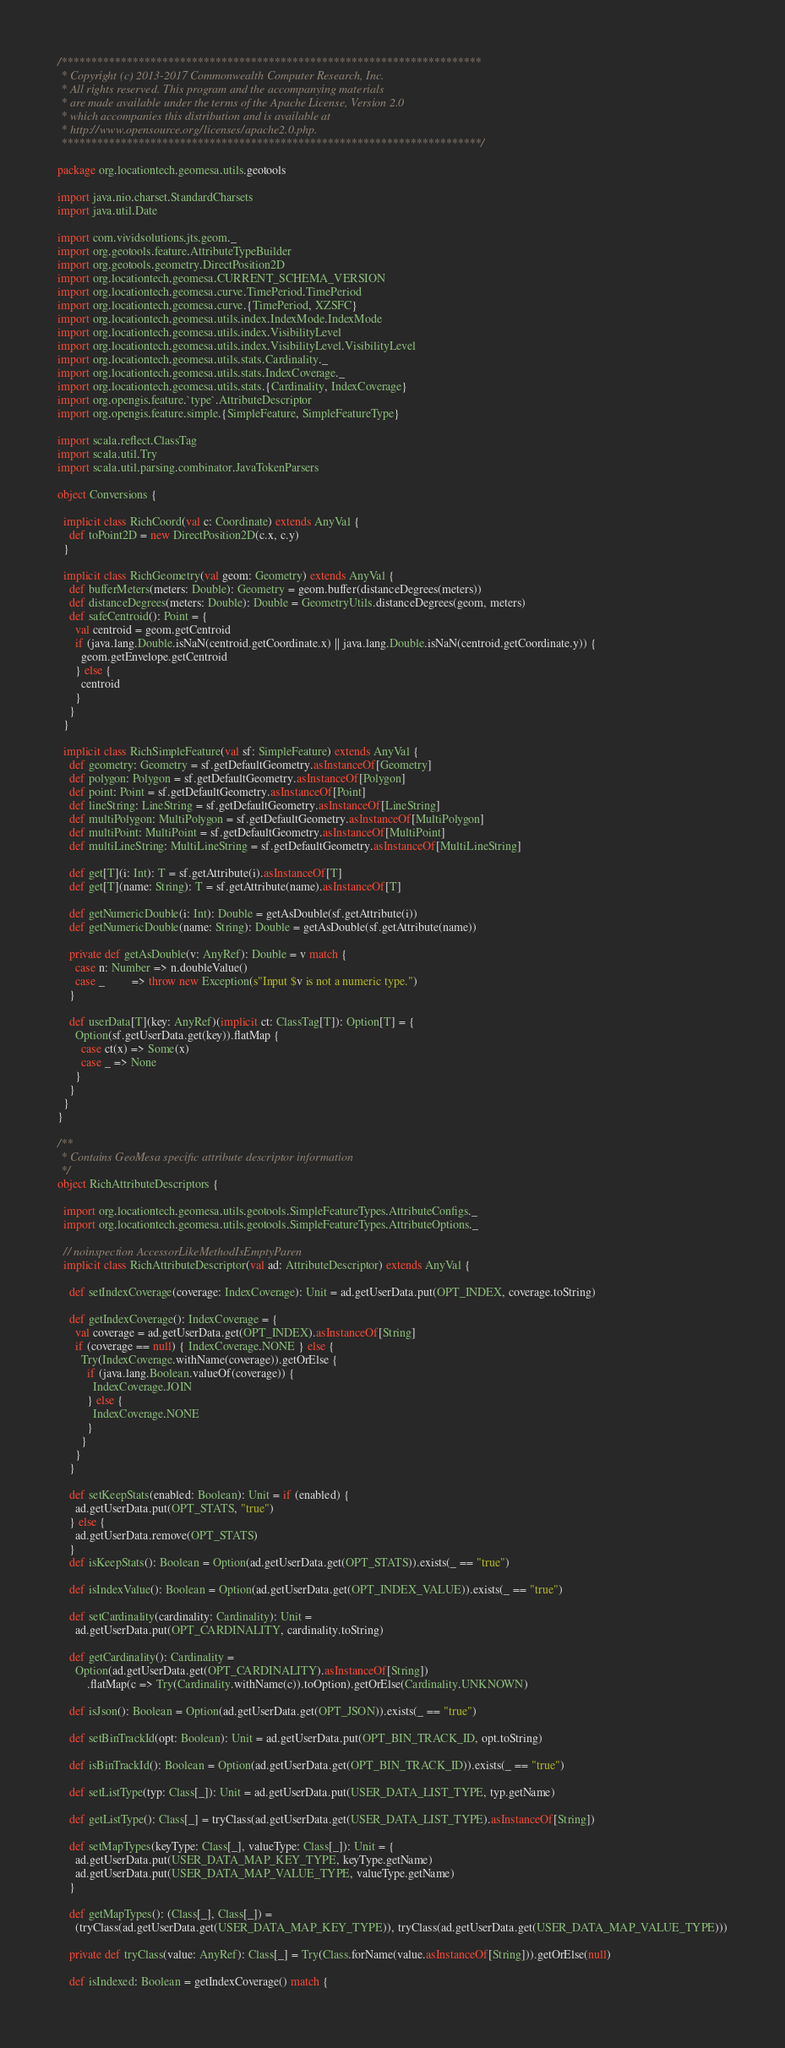Convert code to text. <code><loc_0><loc_0><loc_500><loc_500><_Scala_>/***********************************************************************
 * Copyright (c) 2013-2017 Commonwealth Computer Research, Inc.
 * All rights reserved. This program and the accompanying materials
 * are made available under the terms of the Apache License, Version 2.0
 * which accompanies this distribution and is available at
 * http://www.opensource.org/licenses/apache2.0.php.
 ***********************************************************************/

package org.locationtech.geomesa.utils.geotools

import java.nio.charset.StandardCharsets
import java.util.Date

import com.vividsolutions.jts.geom._
import org.geotools.feature.AttributeTypeBuilder
import org.geotools.geometry.DirectPosition2D
import org.locationtech.geomesa.CURRENT_SCHEMA_VERSION
import org.locationtech.geomesa.curve.TimePeriod.TimePeriod
import org.locationtech.geomesa.curve.{TimePeriod, XZSFC}
import org.locationtech.geomesa.utils.index.IndexMode.IndexMode
import org.locationtech.geomesa.utils.index.VisibilityLevel
import org.locationtech.geomesa.utils.index.VisibilityLevel.VisibilityLevel
import org.locationtech.geomesa.utils.stats.Cardinality._
import org.locationtech.geomesa.utils.stats.IndexCoverage._
import org.locationtech.geomesa.utils.stats.{Cardinality, IndexCoverage}
import org.opengis.feature.`type`.AttributeDescriptor
import org.opengis.feature.simple.{SimpleFeature, SimpleFeatureType}

import scala.reflect.ClassTag
import scala.util.Try
import scala.util.parsing.combinator.JavaTokenParsers

object Conversions {

  implicit class RichCoord(val c: Coordinate) extends AnyVal {
    def toPoint2D = new DirectPosition2D(c.x, c.y)
  }

  implicit class RichGeometry(val geom: Geometry) extends AnyVal {
    def bufferMeters(meters: Double): Geometry = geom.buffer(distanceDegrees(meters))
    def distanceDegrees(meters: Double): Double = GeometryUtils.distanceDegrees(geom, meters)
    def safeCentroid(): Point = {
      val centroid = geom.getCentroid
      if (java.lang.Double.isNaN(centroid.getCoordinate.x) || java.lang.Double.isNaN(centroid.getCoordinate.y)) {
        geom.getEnvelope.getCentroid
      } else {
        centroid
      }
    }
  }

  implicit class RichSimpleFeature(val sf: SimpleFeature) extends AnyVal {
    def geometry: Geometry = sf.getDefaultGeometry.asInstanceOf[Geometry]
    def polygon: Polygon = sf.getDefaultGeometry.asInstanceOf[Polygon]
    def point: Point = sf.getDefaultGeometry.asInstanceOf[Point]
    def lineString: LineString = sf.getDefaultGeometry.asInstanceOf[LineString]
    def multiPolygon: MultiPolygon = sf.getDefaultGeometry.asInstanceOf[MultiPolygon]
    def multiPoint: MultiPoint = sf.getDefaultGeometry.asInstanceOf[MultiPoint]
    def multiLineString: MultiLineString = sf.getDefaultGeometry.asInstanceOf[MultiLineString]

    def get[T](i: Int): T = sf.getAttribute(i).asInstanceOf[T]
    def get[T](name: String): T = sf.getAttribute(name).asInstanceOf[T]

    def getNumericDouble(i: Int): Double = getAsDouble(sf.getAttribute(i))
    def getNumericDouble(name: String): Double = getAsDouble(sf.getAttribute(name))

    private def getAsDouble(v: AnyRef): Double = v match {
      case n: Number => n.doubleValue()
      case _         => throw new Exception(s"Input $v is not a numeric type.")
    }

    def userData[T](key: AnyRef)(implicit ct: ClassTag[T]): Option[T] = {
      Option(sf.getUserData.get(key)).flatMap {
        case ct(x) => Some(x)
        case _ => None
      }
    }
  }
}

/**
 * Contains GeoMesa specific attribute descriptor information
 */
object RichAttributeDescriptors {

  import org.locationtech.geomesa.utils.geotools.SimpleFeatureTypes.AttributeConfigs._
  import org.locationtech.geomesa.utils.geotools.SimpleFeatureTypes.AttributeOptions._

  // noinspection AccessorLikeMethodIsEmptyParen
  implicit class RichAttributeDescriptor(val ad: AttributeDescriptor) extends AnyVal {

    def setIndexCoverage(coverage: IndexCoverage): Unit = ad.getUserData.put(OPT_INDEX, coverage.toString)

    def getIndexCoverage(): IndexCoverage = {
      val coverage = ad.getUserData.get(OPT_INDEX).asInstanceOf[String]
      if (coverage == null) { IndexCoverage.NONE } else {
        Try(IndexCoverage.withName(coverage)).getOrElse {
          if (java.lang.Boolean.valueOf(coverage)) {
            IndexCoverage.JOIN
          } else {
            IndexCoverage.NONE
          }
        }
      }
    }

    def setKeepStats(enabled: Boolean): Unit = if (enabled) {
      ad.getUserData.put(OPT_STATS, "true")
    } else {
      ad.getUserData.remove(OPT_STATS)
    }
    def isKeepStats(): Boolean = Option(ad.getUserData.get(OPT_STATS)).exists(_ == "true")

    def isIndexValue(): Boolean = Option(ad.getUserData.get(OPT_INDEX_VALUE)).exists(_ == "true")

    def setCardinality(cardinality: Cardinality): Unit =
      ad.getUserData.put(OPT_CARDINALITY, cardinality.toString)

    def getCardinality(): Cardinality =
      Option(ad.getUserData.get(OPT_CARDINALITY).asInstanceOf[String])
          .flatMap(c => Try(Cardinality.withName(c)).toOption).getOrElse(Cardinality.UNKNOWN)

    def isJson(): Boolean = Option(ad.getUserData.get(OPT_JSON)).exists(_ == "true")

    def setBinTrackId(opt: Boolean): Unit = ad.getUserData.put(OPT_BIN_TRACK_ID, opt.toString)

    def isBinTrackId(): Boolean = Option(ad.getUserData.get(OPT_BIN_TRACK_ID)).exists(_ == "true")

    def setListType(typ: Class[_]): Unit = ad.getUserData.put(USER_DATA_LIST_TYPE, typ.getName)

    def getListType(): Class[_] = tryClass(ad.getUserData.get(USER_DATA_LIST_TYPE).asInstanceOf[String])

    def setMapTypes(keyType: Class[_], valueType: Class[_]): Unit = {
      ad.getUserData.put(USER_DATA_MAP_KEY_TYPE, keyType.getName)
      ad.getUserData.put(USER_DATA_MAP_VALUE_TYPE, valueType.getName)
    }

    def getMapTypes(): (Class[_], Class[_]) =
      (tryClass(ad.getUserData.get(USER_DATA_MAP_KEY_TYPE)), tryClass(ad.getUserData.get(USER_DATA_MAP_VALUE_TYPE)))

    private def tryClass(value: AnyRef): Class[_] = Try(Class.forName(value.asInstanceOf[String])).getOrElse(null)

    def isIndexed: Boolean = getIndexCoverage() match {</code> 